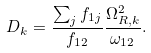<formula> <loc_0><loc_0><loc_500><loc_500>D _ { k } = \frac { \sum _ { j } f _ { 1 j } } { f _ { 1 2 } } \frac { \Omega _ { R , k } ^ { 2 } } { \omega _ { 1 2 } } .</formula> 